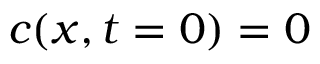Convert formula to latex. <formula><loc_0><loc_0><loc_500><loc_500>c ( x , t = 0 ) = 0</formula> 